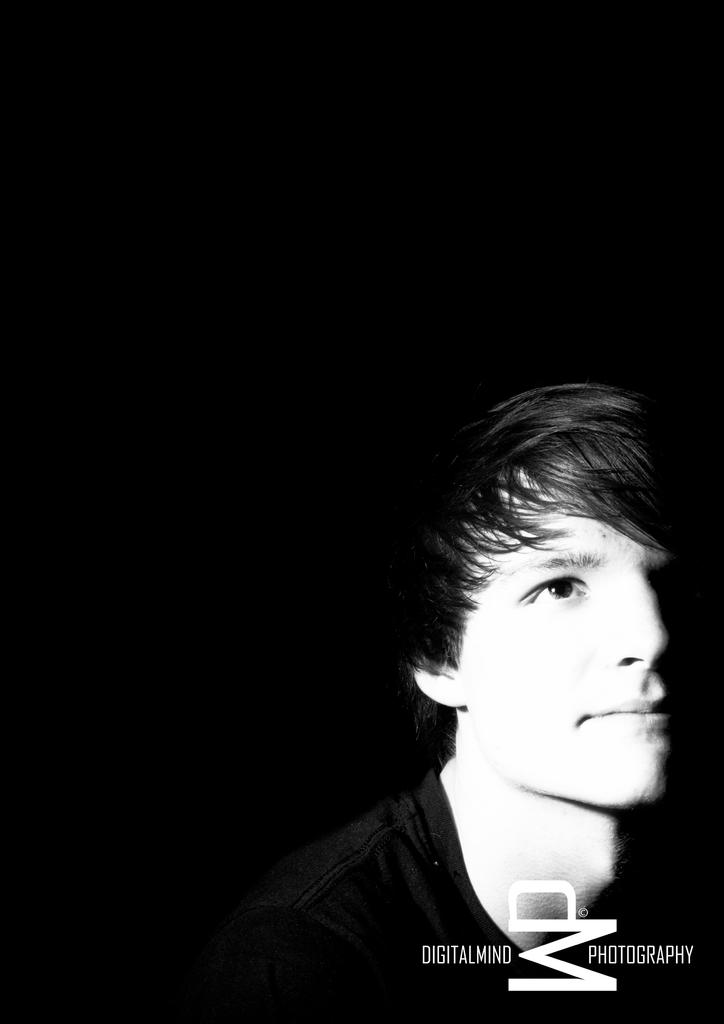What is the color scheme of the image? The image is black and white. Where is the man located in the image? The man is on the right side of the image. What can be found at the bottom of the image? There is text written at the bottom of the image. How many brothers does the man have in the image? There is no information about the man's brothers in the image. What type of verse is recited by the man in the image? There is no man reciting a verse in the image; it is a black and white photograph with text at the bottom. 